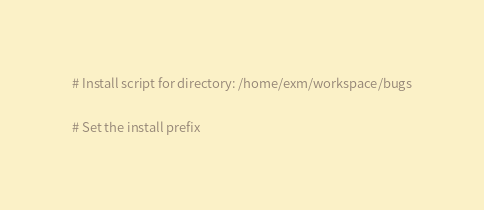<code> <loc_0><loc_0><loc_500><loc_500><_CMake_># Install script for directory: /home/exm/workspace/bugs

# Set the install prefix</code> 